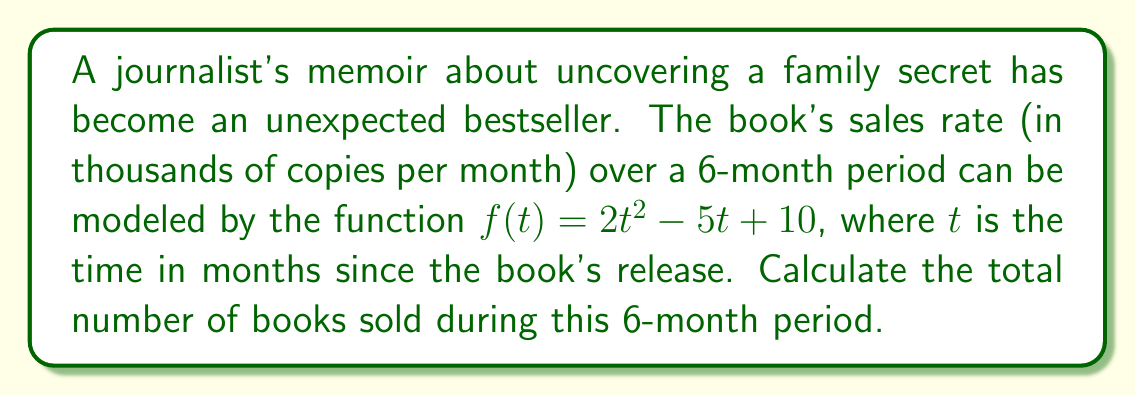Can you solve this math problem? To find the total number of books sold during the 6-month period, we need to calculate the area under the curve of the sales rate function from $t=0$ to $t=6$. This can be done using definite integration.

1. The function representing the sales rate is:
   $f(t) = 2t^2 - 5t + 10$

2. To find the total number of books sold, we integrate this function from 0 to 6:
   $$\int_0^6 (2t^2 - 5t + 10) dt$$

3. Integrate each term:
   $$\left[ \frac{2t^3}{3} - \frac{5t^2}{2} + 10t \right]_0^6$$

4. Evaluate the integral:
   $$\left( \frac{2(6^3)}{3} - \frac{5(6^2)}{2} + 10(6) \right) - \left( \frac{2(0^3)}{3} - \frac{5(0^2)}{2} + 10(0) \right)$$

5. Simplify:
   $$\left( 144 - 90 + 60 \right) - (0)$$
   $$= 114$$

6. Since the sales rate was in thousands of copies per month, multiply the result by 1000:
   $114 * 1000 = 114,000$

Therefore, the total number of books sold during the 6-month period is 114,000 copies.
Answer: 114,000 books 